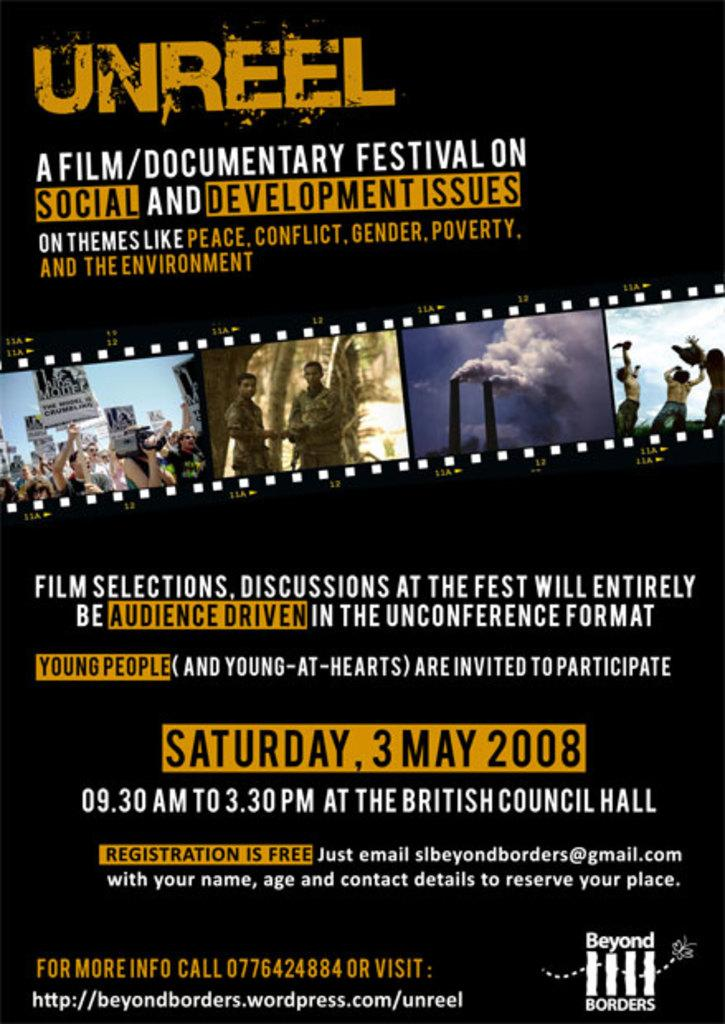<image>
Give a short and clear explanation of the subsequent image. The Unreel Film and Documentary Festival is going to take place on Saturday, May 3rd, 2008. 